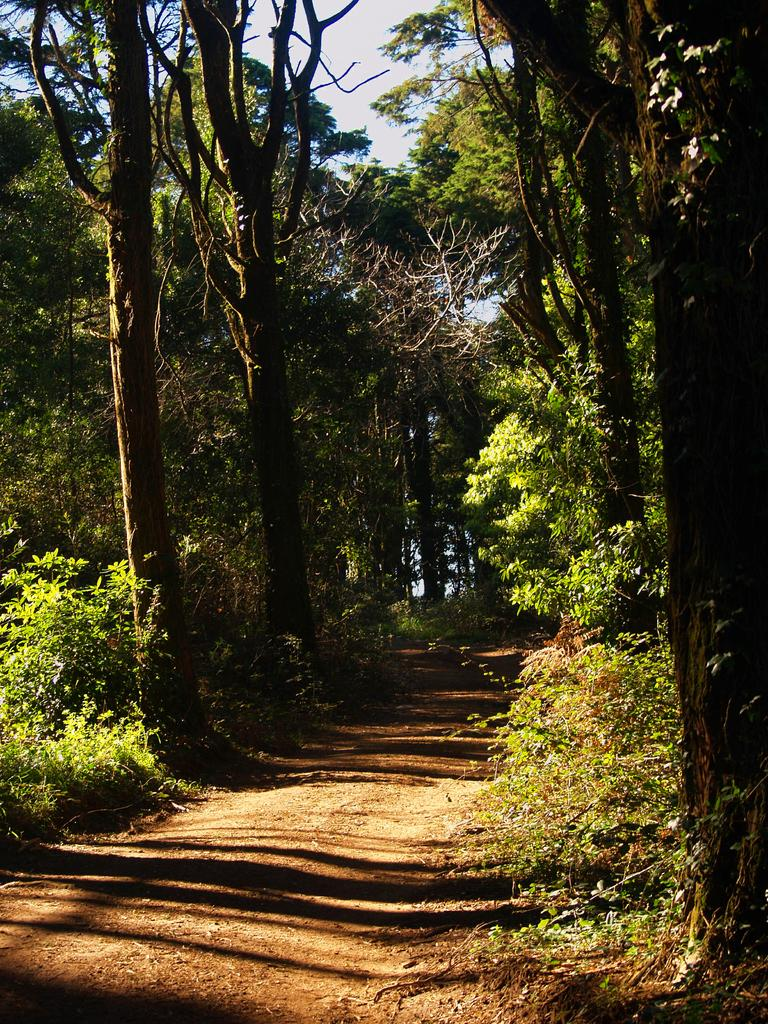What type of vegetation can be seen on both sides of the image? There are plants and trees on both the right and left sides of the image. What is visible at the bottom of the image? Soil is visible at the bottom of the image. What is visible at the top of the image? The sky is visible at the top of the image. Are there any dinosaurs visible in the image? No, there are no dinosaurs present in the image. What type of vest can be seen on the plants in the image? There are no vests present in the image, as plants do not wear clothing. 